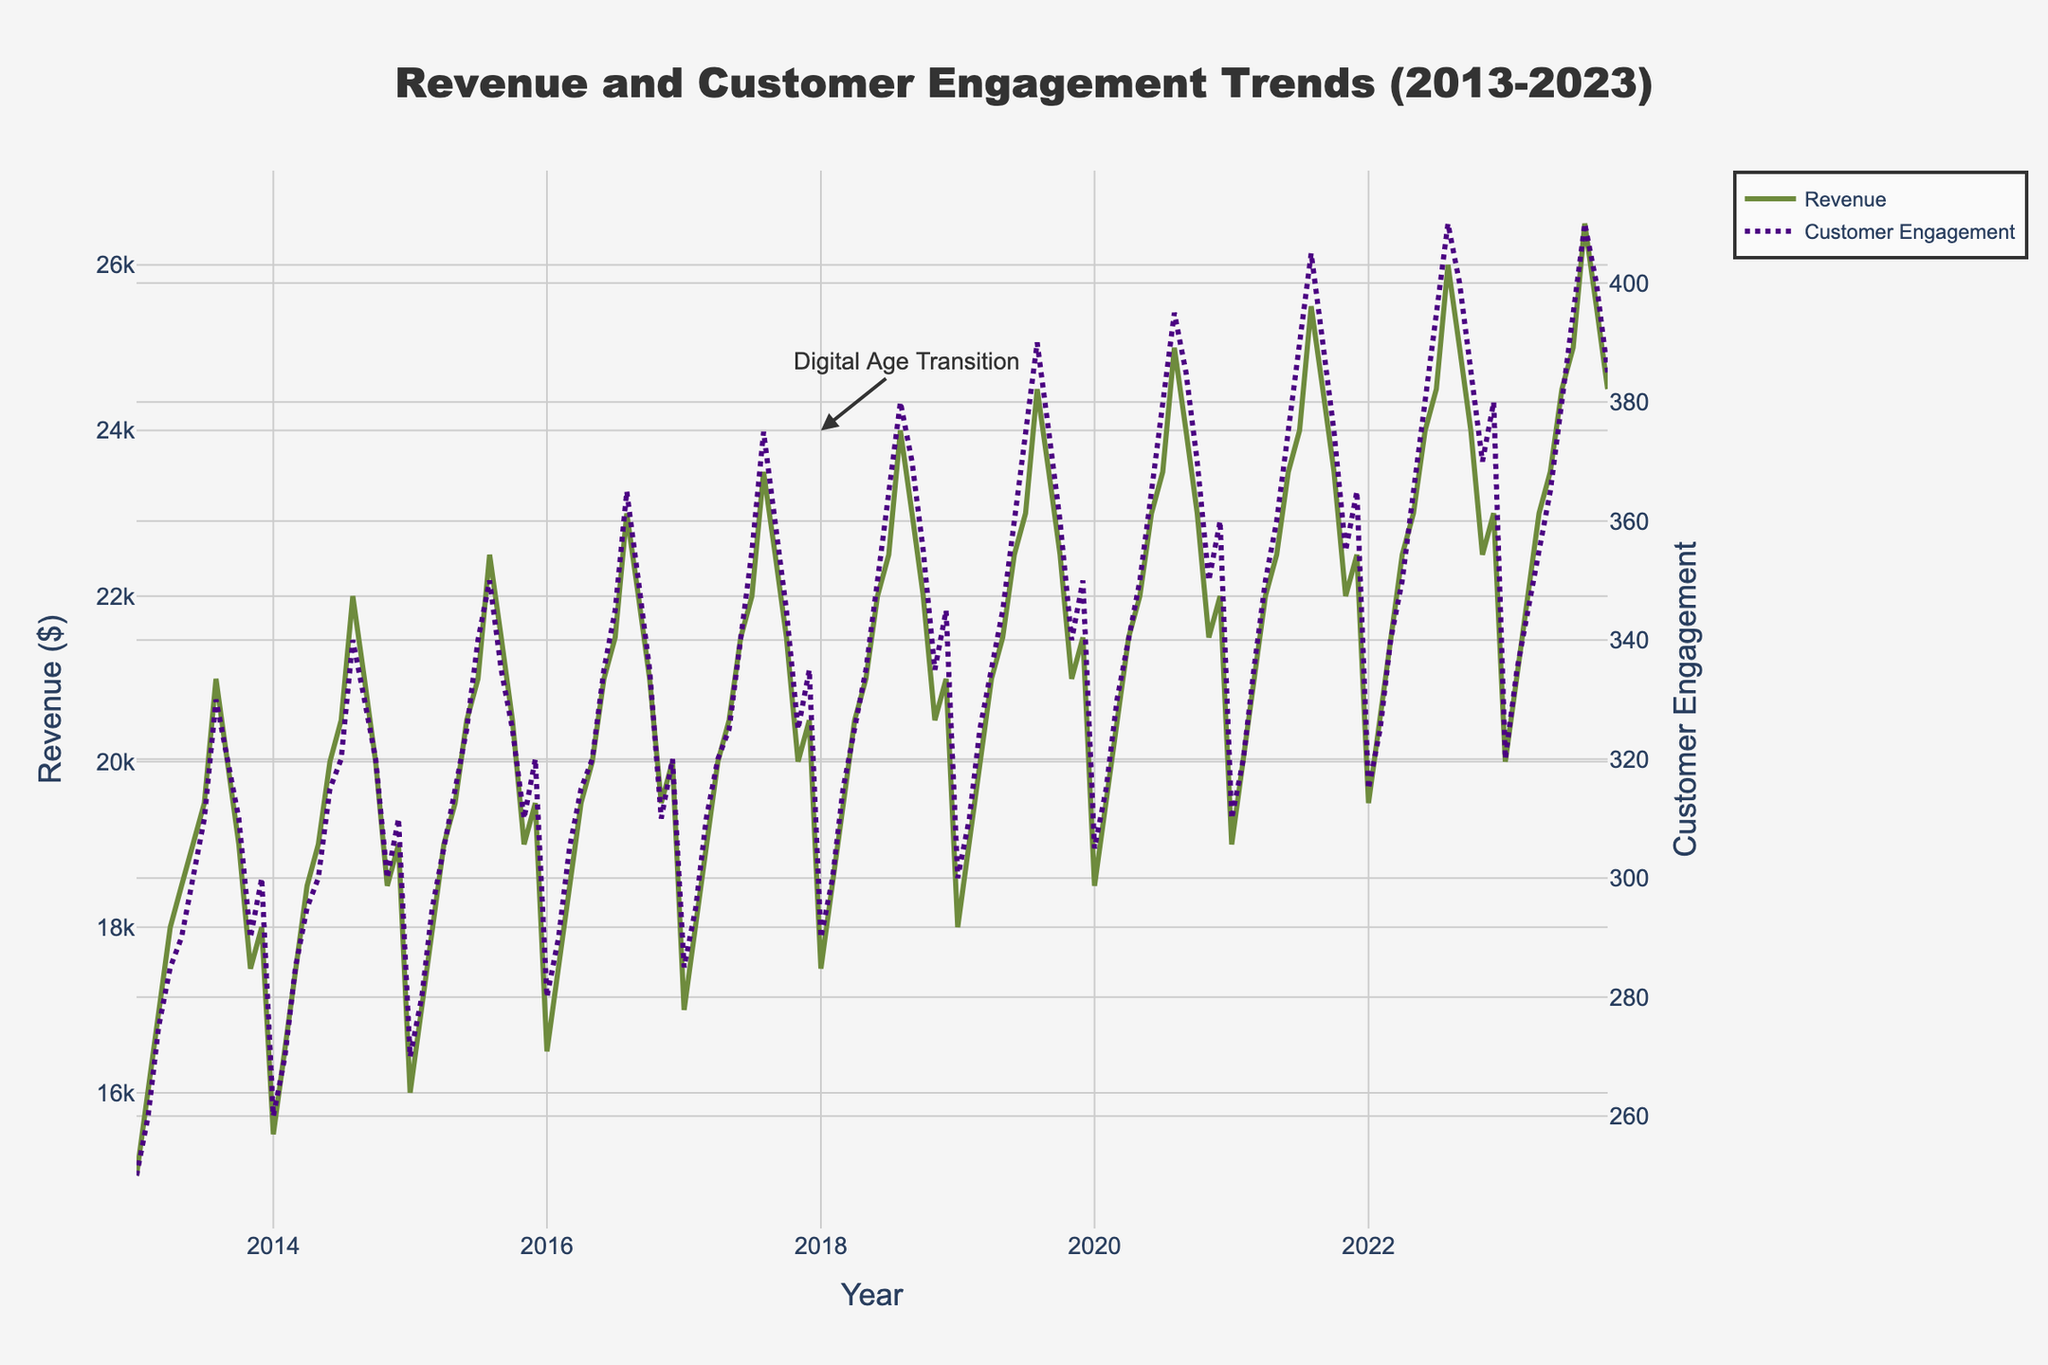What does the title of the figure indicate? The title of the figure indicates the content and time period of the plot. It says "Revenue and Customer Engagement Trends (2013-2023)", meaning the figure displays the trends of revenue and customer engagement over the years 2013 to 2023.
Answer: Revenue and Customer Engagement Trends (2013-2023) What color are the lines representing Revenue and Customer Engagement? Refer to the lines in the plot, the Revenue line is represented in green, while the Customer Engagement line is in purple.
Answer: Green and Purple What is the highest value of Revenue shown in the plot and when does it occur? Look at the highest point in the Revenue line. The highest value of Revenue is $26,500, which occurs in August 2023.
Answer: $26,500 in August 2023 How has Customer Engagement trended from January 2013 to October 2023? Observe the trend of the Customer Engagement line from the start to the end. Customer Engagement generally increases over the period, with seasonal peaks each year, ending higher in October 2023 than it started in January 2013.
Answer: Increasing with seasonal peaks What is the trend in Revenue during the summer months each year? Focus on the months of June to August for each year. Revenue tends to peak during these summer months each year, indicating a seasonal trend.
Answer: Revenue peaks during the summer How does the annual trend in Customer Engagement compare with Revenue over the decade? Compare the lines for yearly trends. Both Revenue and Customer Engagement show an overall increasing trend with seasonal peaks, although specific peaks and troughs may not coincide exactly.
Answer: Both increase with seasonal peaks What annotation is present in the plot, and what does it signify? Look for any text annotations on the plot. The annotation "Digital Age Transition" is present around January 2018, indicating a possible significant change or trend starting in 2018.
Answer: Digital Age Transition in January 2018 During which month and year did both Revenue and Customer Engagement show a clear simultaneous increase? Look at points where both lines clearly go up simultaneously. One clear simultaneous increase occurs in August 2020 where both Revenue and Customer Engagement significantly rise.
Answer: August 2020 What were the Revenue and Customer Engagement values in January 2023? Refer to the data points at January 2023 on the respective lines. Revenue was $20,000 and Customer Engagement was 320 in January 2023.
Answer: Revenue: $20,000, Customer Engagement: 320 